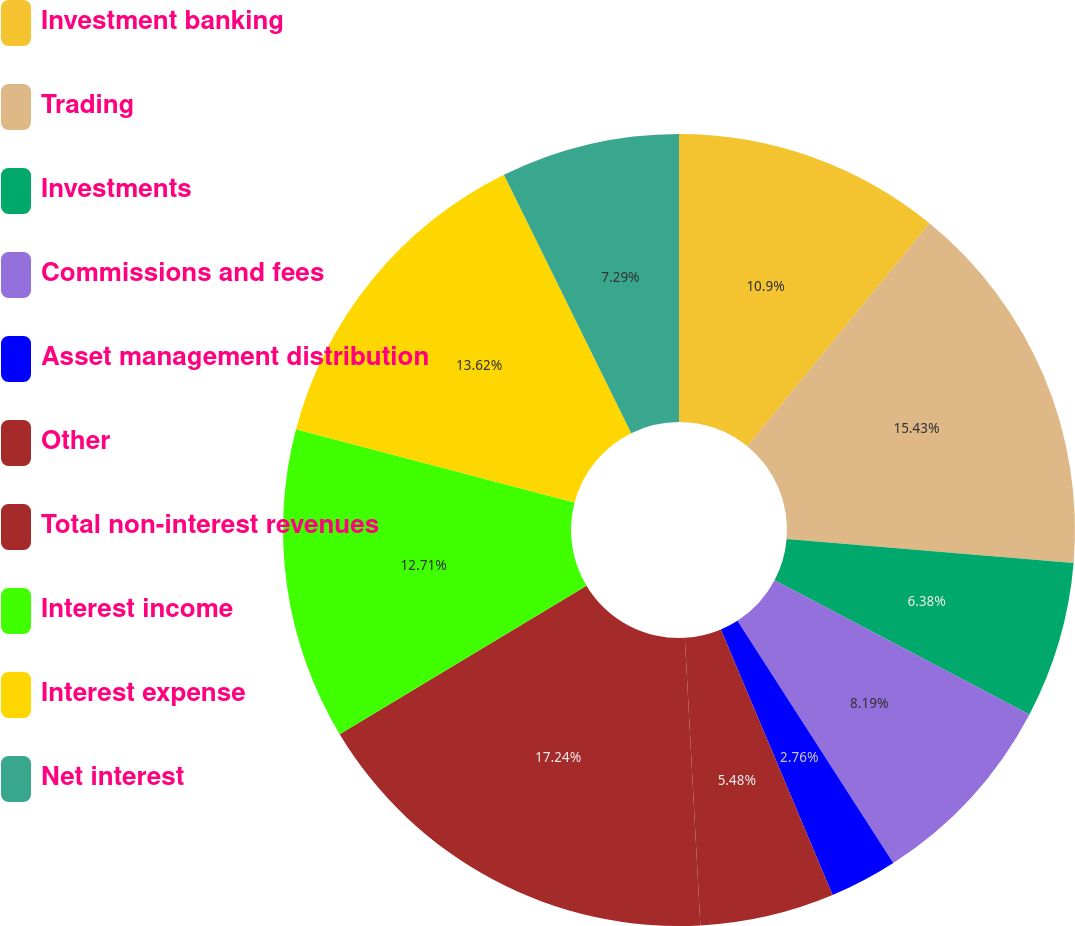<chart> <loc_0><loc_0><loc_500><loc_500><pie_chart><fcel>Investment banking<fcel>Trading<fcel>Investments<fcel>Commissions and fees<fcel>Asset management distribution<fcel>Other<fcel>Total non-interest revenues<fcel>Interest income<fcel>Interest expense<fcel>Net interest<nl><fcel>10.9%<fcel>15.43%<fcel>6.38%<fcel>8.19%<fcel>2.76%<fcel>5.48%<fcel>17.24%<fcel>12.71%<fcel>13.62%<fcel>7.29%<nl></chart> 